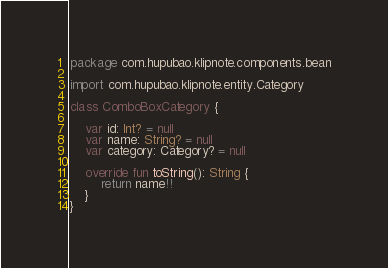Convert code to text. <code><loc_0><loc_0><loc_500><loc_500><_Kotlin_>package com.hupubao.klipnote.components.bean

import com.hupubao.klipnote.entity.Category

class ComboBoxCategory {

    var id: Int? = null
    var name: String? = null
    var category: Category? = null

    override fun toString(): String {
        return name!!
    }
}</code> 